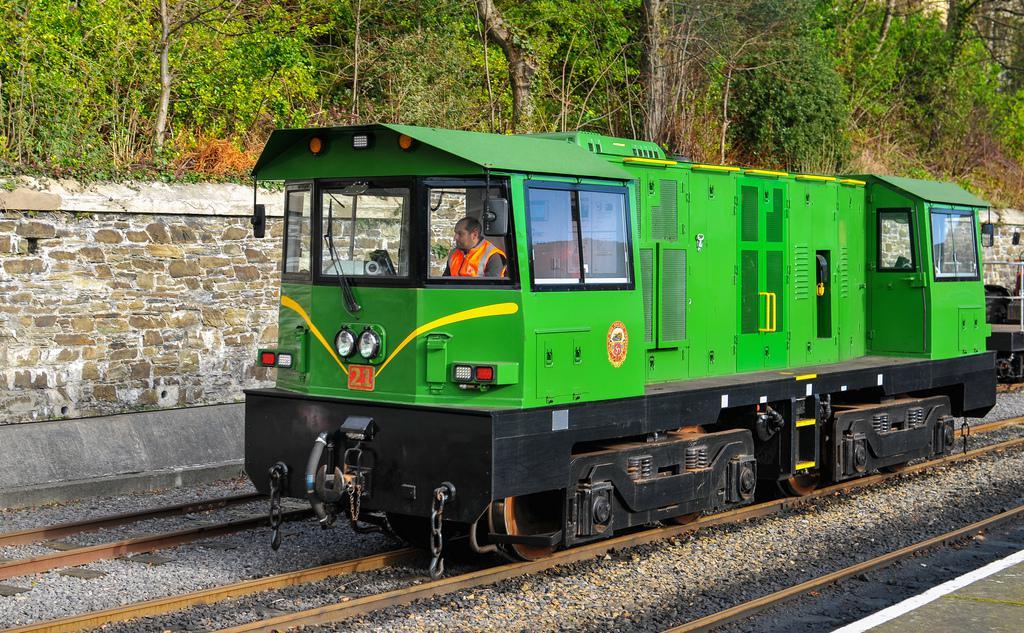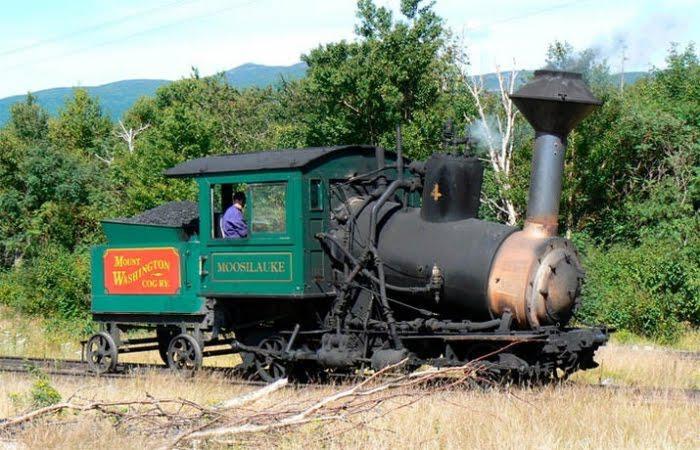The first image is the image on the left, the second image is the image on the right. Assess this claim about the two images: "All the trains depicted feature green coloring.". Correct or not? Answer yes or no. Yes. 